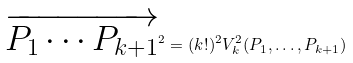<formula> <loc_0><loc_0><loc_500><loc_500>\overrightarrow { P _ { 1 } \cdots P _ { k + 1 } } ^ { 2 } = ( k ! ) ^ { 2 } V _ { k } ^ { 2 } ( P _ { 1 } , \dots , P _ { k + 1 } )</formula> 